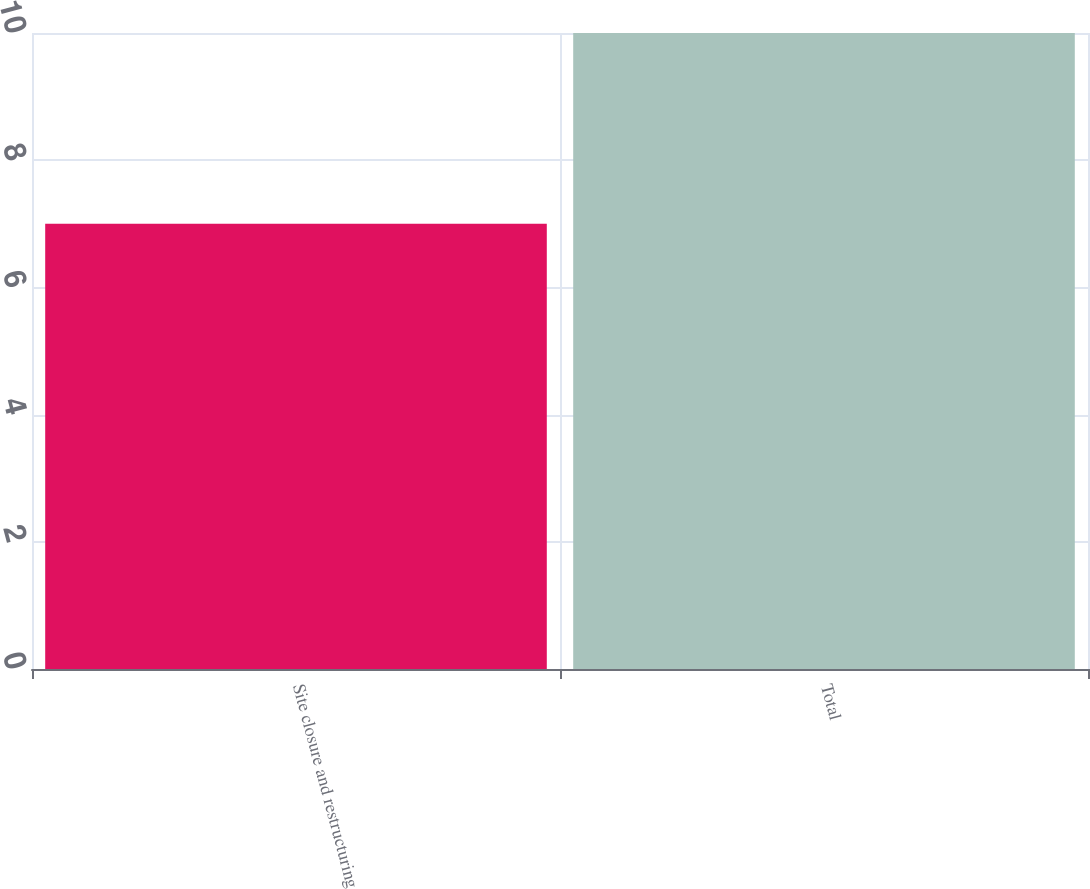Convert chart to OTSL. <chart><loc_0><loc_0><loc_500><loc_500><bar_chart><fcel>Site closure and restructuring<fcel>Total<nl><fcel>7<fcel>10<nl></chart> 